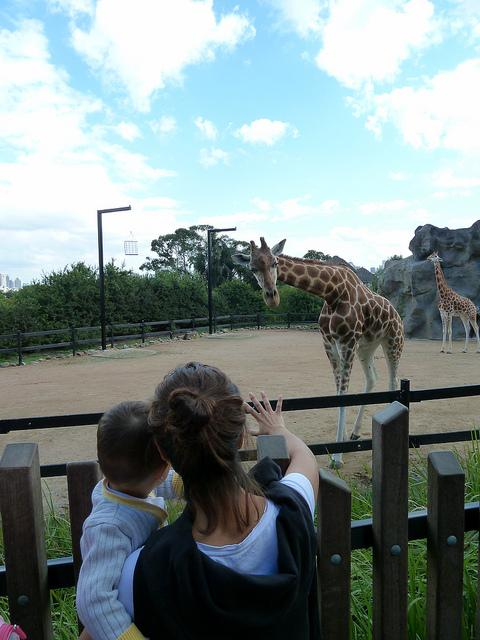What is the hanging basket for? Please explain your reasoning. storing food. There is food hanging up high so the giraffes can eat. 